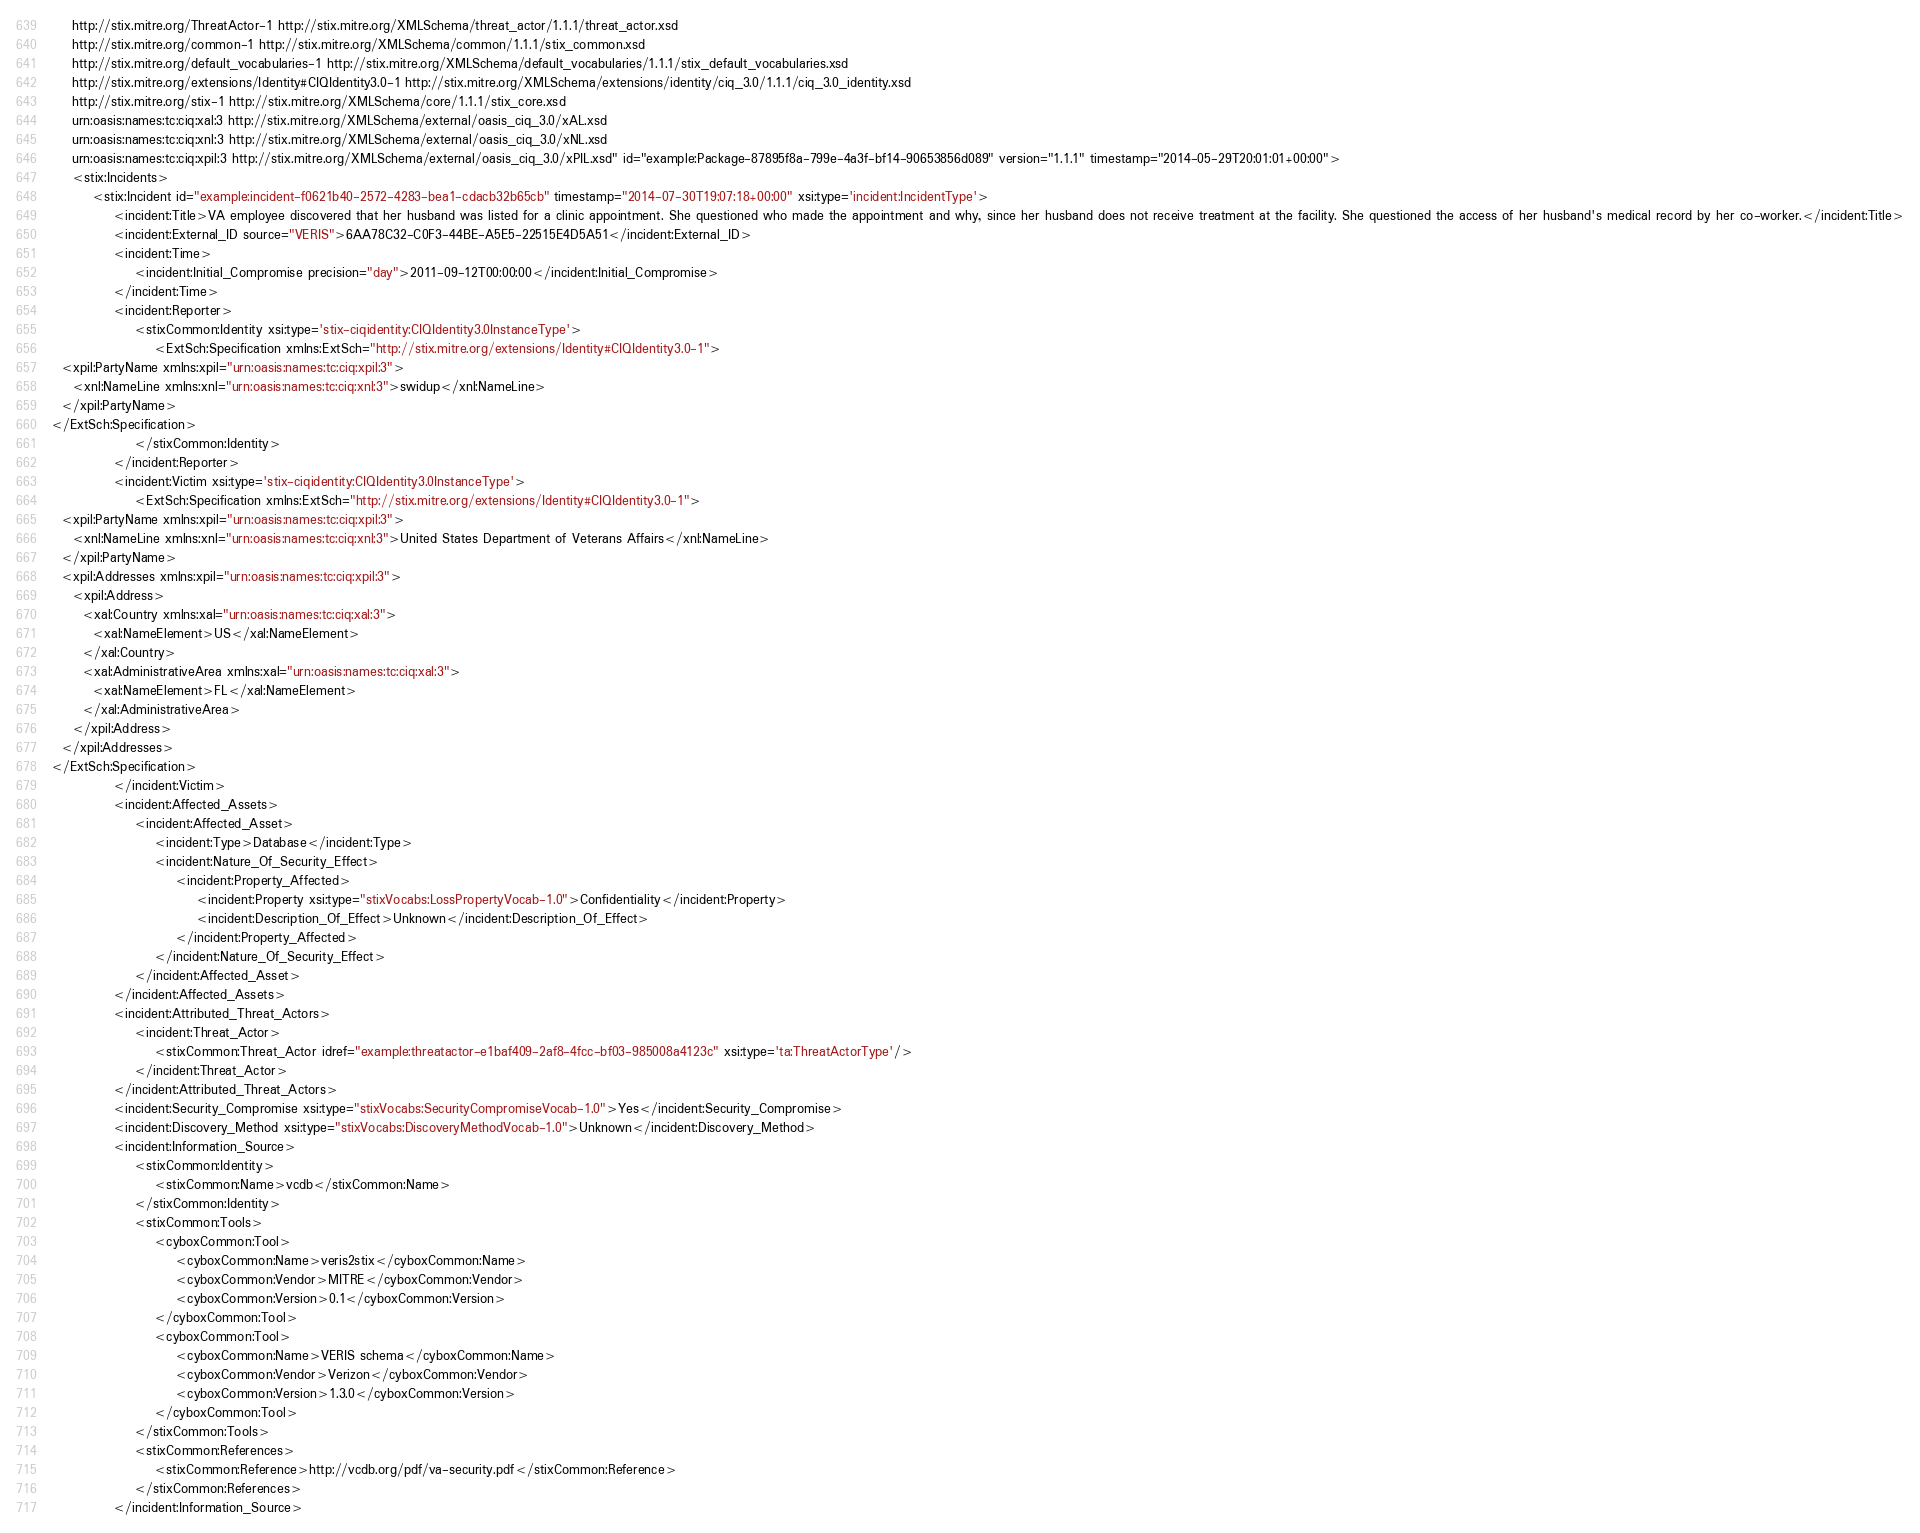Convert code to text. <code><loc_0><loc_0><loc_500><loc_500><_XML_>	http://stix.mitre.org/ThreatActor-1 http://stix.mitre.org/XMLSchema/threat_actor/1.1.1/threat_actor.xsd
	http://stix.mitre.org/common-1 http://stix.mitre.org/XMLSchema/common/1.1.1/stix_common.xsd
	http://stix.mitre.org/default_vocabularies-1 http://stix.mitre.org/XMLSchema/default_vocabularies/1.1.1/stix_default_vocabularies.xsd
	http://stix.mitre.org/extensions/Identity#CIQIdentity3.0-1 http://stix.mitre.org/XMLSchema/extensions/identity/ciq_3.0/1.1.1/ciq_3.0_identity.xsd
	http://stix.mitre.org/stix-1 http://stix.mitre.org/XMLSchema/core/1.1.1/stix_core.xsd
	urn:oasis:names:tc:ciq:xal:3 http://stix.mitre.org/XMLSchema/external/oasis_ciq_3.0/xAL.xsd
	urn:oasis:names:tc:ciq:xnl:3 http://stix.mitre.org/XMLSchema/external/oasis_ciq_3.0/xNL.xsd
	urn:oasis:names:tc:ciq:xpil:3 http://stix.mitre.org/XMLSchema/external/oasis_ciq_3.0/xPIL.xsd" id="example:Package-87895f8a-799e-4a3f-bf14-90653856d089" version="1.1.1" timestamp="2014-05-29T20:01:01+00:00">
    <stix:Incidents>
        <stix:Incident id="example:incident-f0621b40-2572-4283-bea1-cdacb32b65cb" timestamp="2014-07-30T19:07:18+00:00" xsi:type='incident:IncidentType'>
            <incident:Title>VA employee discovered that her husband was listed for a clinic appointment. She questioned who made the appointment and why, since her husband does not receive treatment at the facility. She questioned the access of her husband's medical record by her co-worker.</incident:Title>
            <incident:External_ID source="VERIS">6AA78C32-C0F3-44BE-A5E5-22515E4D5A51</incident:External_ID>
            <incident:Time>
                <incident:Initial_Compromise precision="day">2011-09-12T00:00:00</incident:Initial_Compromise>
            </incident:Time>
            <incident:Reporter>
                <stixCommon:Identity xsi:type='stix-ciqidentity:CIQIdentity3.0InstanceType'>
                    <ExtSch:Specification xmlns:ExtSch="http://stix.mitre.org/extensions/Identity#CIQIdentity3.0-1">
  <xpil:PartyName xmlns:xpil="urn:oasis:names:tc:ciq:xpil:3">
    <xnl:NameLine xmlns:xnl="urn:oasis:names:tc:ciq:xnl:3">swidup</xnl:NameLine>
  </xpil:PartyName>
</ExtSch:Specification>
                </stixCommon:Identity>
            </incident:Reporter>
            <incident:Victim xsi:type='stix-ciqidentity:CIQIdentity3.0InstanceType'>
                <ExtSch:Specification xmlns:ExtSch="http://stix.mitre.org/extensions/Identity#CIQIdentity3.0-1">
  <xpil:PartyName xmlns:xpil="urn:oasis:names:tc:ciq:xpil:3">
    <xnl:NameLine xmlns:xnl="urn:oasis:names:tc:ciq:xnl:3">United States Department of Veterans Affairs</xnl:NameLine>
  </xpil:PartyName>
  <xpil:Addresses xmlns:xpil="urn:oasis:names:tc:ciq:xpil:3">
    <xpil:Address>
      <xal:Country xmlns:xal="urn:oasis:names:tc:ciq:xal:3">
        <xal:NameElement>US</xal:NameElement>
      </xal:Country>
      <xal:AdministrativeArea xmlns:xal="urn:oasis:names:tc:ciq:xal:3">
        <xal:NameElement>FL</xal:NameElement>
      </xal:AdministrativeArea>
    </xpil:Address>
  </xpil:Addresses>
</ExtSch:Specification>
            </incident:Victim>
            <incident:Affected_Assets>
                <incident:Affected_Asset>
                    <incident:Type>Database</incident:Type>
                    <incident:Nature_Of_Security_Effect>
                        <incident:Property_Affected>
                            <incident:Property xsi:type="stixVocabs:LossPropertyVocab-1.0">Confidentiality</incident:Property>
                            <incident:Description_Of_Effect>Unknown</incident:Description_Of_Effect>
                        </incident:Property_Affected>
                    </incident:Nature_Of_Security_Effect>
                </incident:Affected_Asset>
            </incident:Affected_Assets>
            <incident:Attributed_Threat_Actors>
                <incident:Threat_Actor>
                    <stixCommon:Threat_Actor idref="example:threatactor-e1baf409-2af8-4fcc-bf03-985008a4123c" xsi:type='ta:ThreatActorType'/>
                </incident:Threat_Actor>
            </incident:Attributed_Threat_Actors>
            <incident:Security_Compromise xsi:type="stixVocabs:SecurityCompromiseVocab-1.0">Yes</incident:Security_Compromise>
            <incident:Discovery_Method xsi:type="stixVocabs:DiscoveryMethodVocab-1.0">Unknown</incident:Discovery_Method>
            <incident:Information_Source>
                <stixCommon:Identity>
                    <stixCommon:Name>vcdb</stixCommon:Name>
                </stixCommon:Identity>
                <stixCommon:Tools>
                    <cyboxCommon:Tool>
                        <cyboxCommon:Name>veris2stix</cyboxCommon:Name>
                        <cyboxCommon:Vendor>MITRE</cyboxCommon:Vendor>
                        <cyboxCommon:Version>0.1</cyboxCommon:Version>
                    </cyboxCommon:Tool>
                    <cyboxCommon:Tool>
                        <cyboxCommon:Name>VERIS schema</cyboxCommon:Name>
                        <cyboxCommon:Vendor>Verizon</cyboxCommon:Vendor>
                        <cyboxCommon:Version>1.3.0</cyboxCommon:Version>
                    </cyboxCommon:Tool>
                </stixCommon:Tools>
                <stixCommon:References>
                    <stixCommon:Reference>http://vcdb.org/pdf/va-security.pdf</stixCommon:Reference>
                </stixCommon:References>
            </incident:Information_Source></code> 